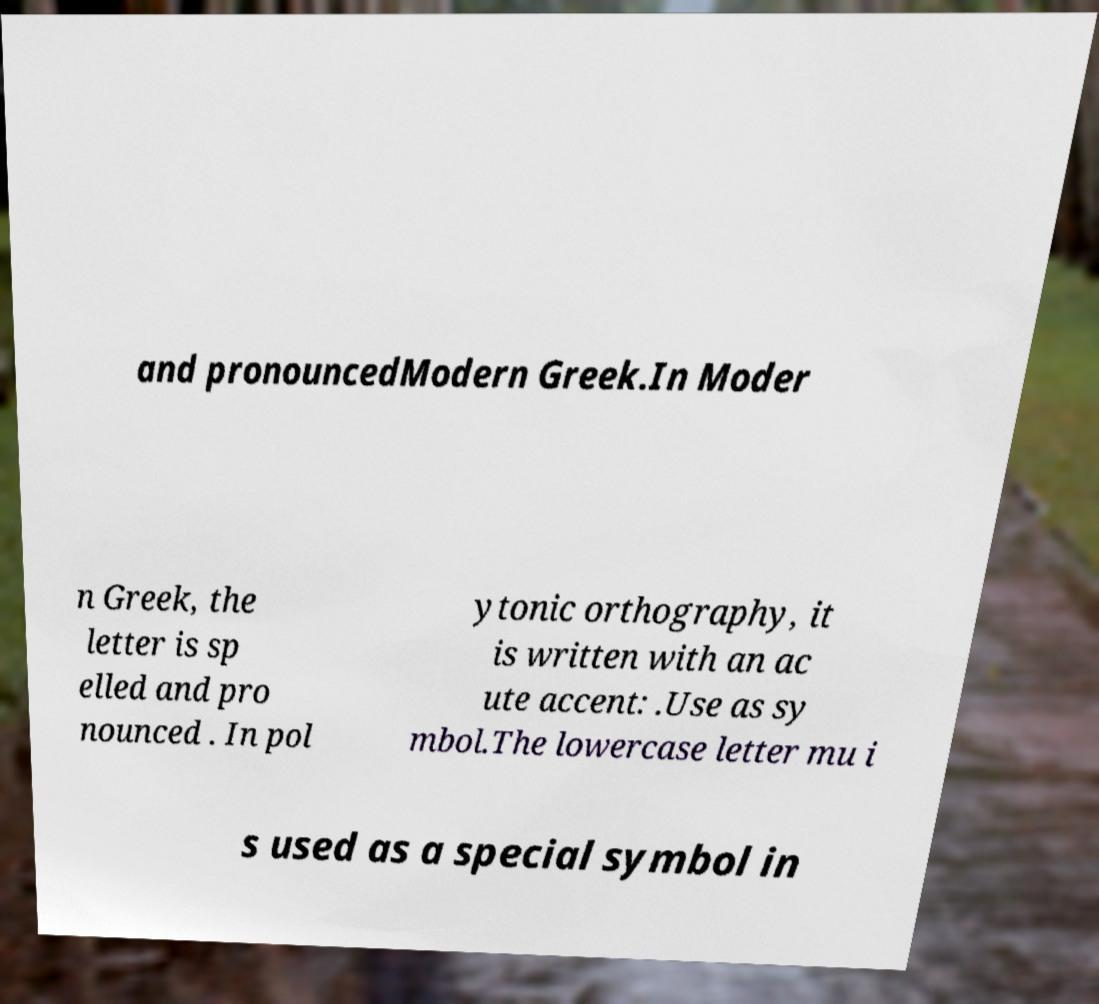Please identify and transcribe the text found in this image. and pronouncedModern Greek.In Moder n Greek, the letter is sp elled and pro nounced . In pol ytonic orthography, it is written with an ac ute accent: .Use as sy mbol.The lowercase letter mu i s used as a special symbol in 